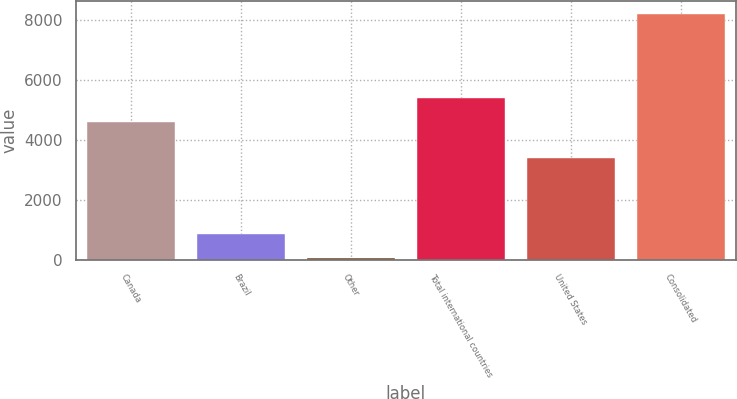Convert chart to OTSL. <chart><loc_0><loc_0><loc_500><loc_500><bar_chart><fcel>Canada<fcel>Brazil<fcel>Other<fcel>Total international countries<fcel>United States<fcel>Consolidated<nl><fcel>4593.2<fcel>875.88<fcel>60.5<fcel>5408.58<fcel>3402<fcel>8214.3<nl></chart> 